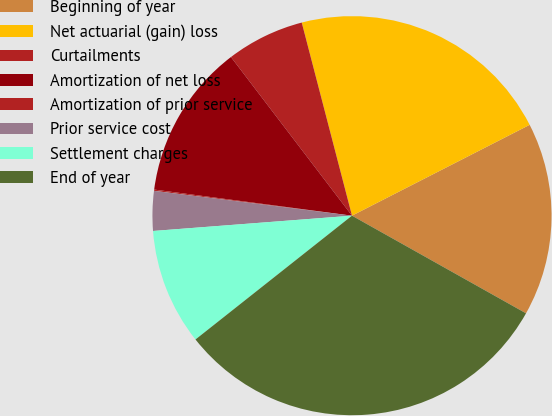Convert chart. <chart><loc_0><loc_0><loc_500><loc_500><pie_chart><fcel>Beginning of year<fcel>Net actuarial (gain) loss<fcel>Curtailments<fcel>Amortization of net loss<fcel>Amortization of prior service<fcel>Prior service cost<fcel>Settlement charges<fcel>End of year<nl><fcel>15.66%<fcel>21.53%<fcel>6.32%<fcel>12.54%<fcel>0.1%<fcel>3.21%<fcel>9.43%<fcel>31.21%<nl></chart> 